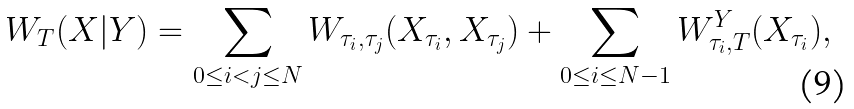Convert formula to latex. <formula><loc_0><loc_0><loc_500><loc_500>W _ { T } ( X | Y ) = \sum _ { 0 \leq i < j \leq N } W _ { \tau _ { i } , \tau _ { j } } ( X _ { \tau _ { i } } , X _ { \tau _ { j } } ) + \sum _ { 0 \leq i \leq N - 1 } W _ { \tau _ { i } , T } ^ { Y } ( X _ { \tau _ { i } } ) ,</formula> 